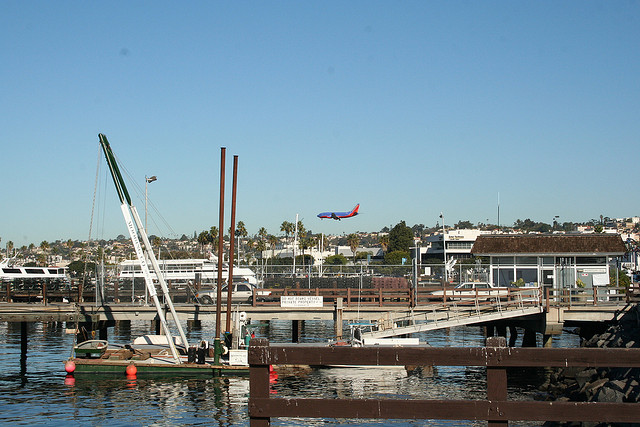Can you describe the area surrounding the body of water? The area surrounding the body of water appears to be a marina or dock, characterized by moored boats, wooden walkways, and a crane, often used for boat maintenance or launching. The background features buildings that suggest a nearby coastal community with a clear sky above. 